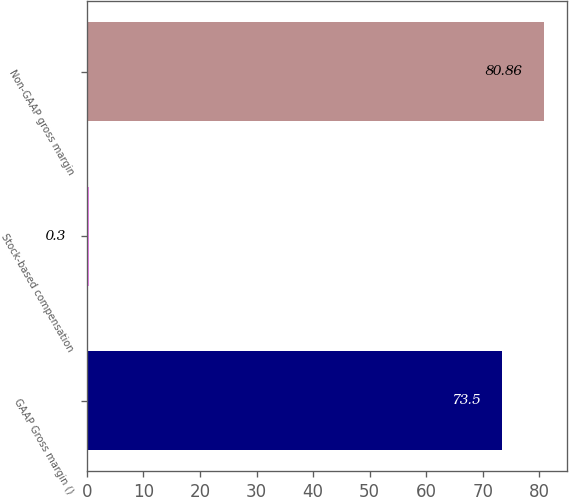Convert chart to OTSL. <chart><loc_0><loc_0><loc_500><loc_500><bar_chart><fcel>GAAP Gross margin ()<fcel>Stock-based compensation<fcel>Non-GAAP gross margin<nl><fcel>73.5<fcel>0.3<fcel>80.86<nl></chart> 